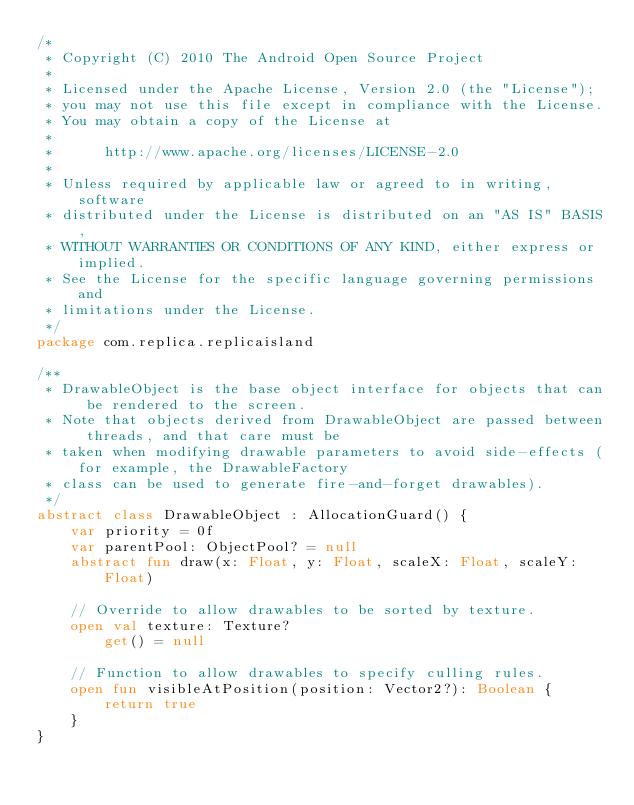<code> <loc_0><loc_0><loc_500><loc_500><_Kotlin_>/*
 * Copyright (C) 2010 The Android Open Source Project
 *
 * Licensed under the Apache License, Version 2.0 (the "License");
 * you may not use this file except in compliance with the License.
 * You may obtain a copy of the License at
 *
 *      http://www.apache.org/licenses/LICENSE-2.0
 *
 * Unless required by applicable law or agreed to in writing, software
 * distributed under the License is distributed on an "AS IS" BASIS,
 * WITHOUT WARRANTIES OR CONDITIONS OF ANY KIND, either express or implied.
 * See the License for the specific language governing permissions and
 * limitations under the License.
 */
package com.replica.replicaisland

/**
 * DrawableObject is the base object interface for objects that can be rendered to the screen.
 * Note that objects derived from DrawableObject are passed between threads, and that care must be
 * taken when modifying drawable parameters to avoid side-effects (for example, the DrawableFactory
 * class can be used to generate fire-and-forget drawables).
 */
abstract class DrawableObject : AllocationGuard() {
    var priority = 0f
    var parentPool: ObjectPool? = null
    abstract fun draw(x: Float, y: Float, scaleX: Float, scaleY: Float)

    // Override to allow drawables to be sorted by texture.
    open val texture: Texture?
        get() = null

    // Function to allow drawables to specify culling rules.
    open fun visibleAtPosition(position: Vector2?): Boolean {
        return true
    }
}</code> 